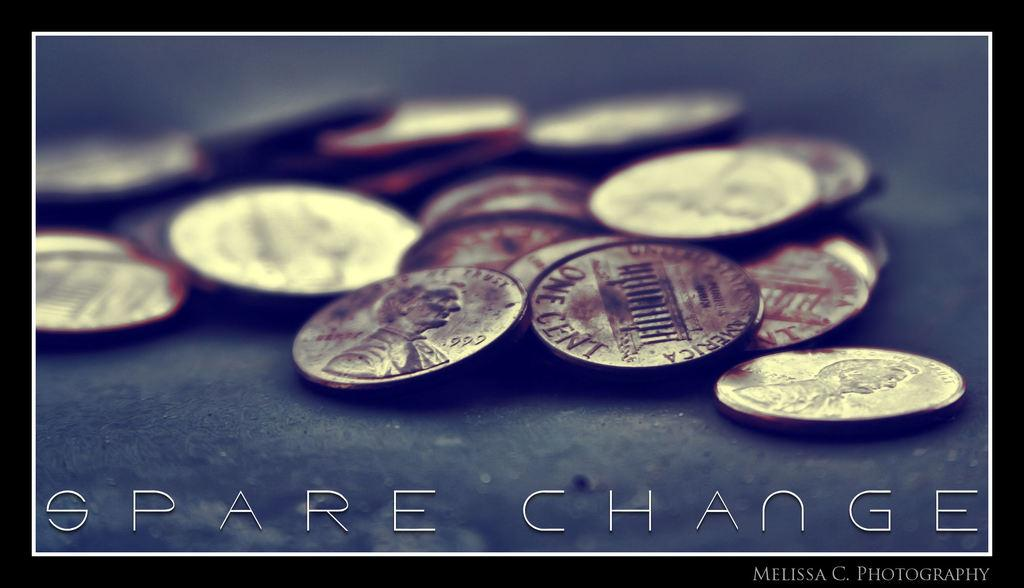<image>
Provide a brief description of the given image. A poster for spare change by Melissa C. 